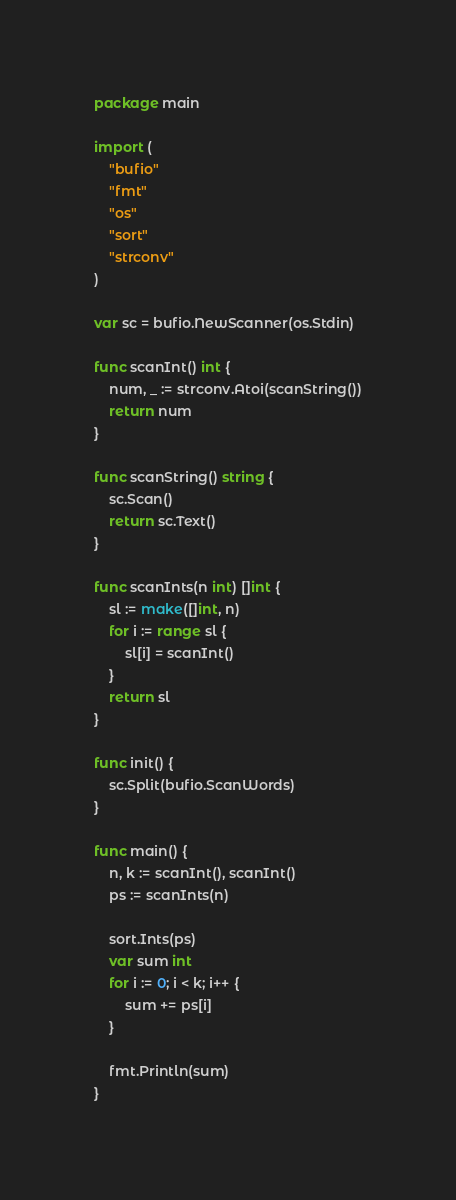Convert code to text. <code><loc_0><loc_0><loc_500><loc_500><_Go_>package main

import (
	"bufio"
	"fmt"
	"os"
	"sort"
	"strconv"
)

var sc = bufio.NewScanner(os.Stdin)

func scanInt() int {
	num, _ := strconv.Atoi(scanString())
	return num
}

func scanString() string {
	sc.Scan()
	return sc.Text()
}

func scanInts(n int) []int {
	sl := make([]int, n)
	for i := range sl {
		sl[i] = scanInt()
	}
	return sl
}

func init() {
	sc.Split(bufio.ScanWords)
}

func main() {
	n, k := scanInt(), scanInt()
	ps := scanInts(n)

	sort.Ints(ps)
	var sum int
	for i := 0; i < k; i++ {
		sum += ps[i]
	}

	fmt.Println(sum)
}
</code> 